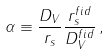<formula> <loc_0><loc_0><loc_500><loc_500>\alpha \equiv \frac { D _ { V } } { r _ { s } } \frac { r _ { s } ^ { f i d } } { D _ { V } ^ { f i d } } \, ,</formula> 